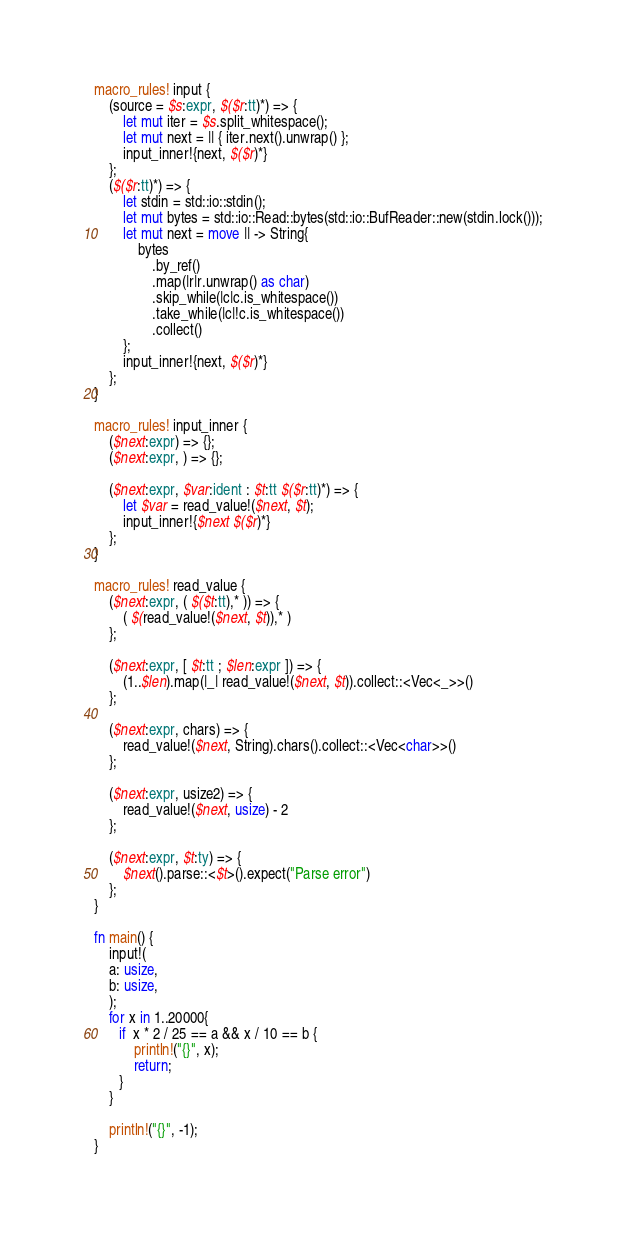Convert code to text. <code><loc_0><loc_0><loc_500><loc_500><_Rust_>macro_rules! input {
    (source = $s:expr, $($r:tt)*) => {
        let mut iter = $s.split_whitespace();
        let mut next = || { iter.next().unwrap() };
        input_inner!{next, $($r)*}
    };
    ($($r:tt)*) => {
        let stdin = std::io::stdin();
        let mut bytes = std::io::Read::bytes(std::io::BufReader::new(stdin.lock()));
        let mut next = move || -> String{
            bytes
                .by_ref()
                .map(|r|r.unwrap() as char)
                .skip_while(|c|c.is_whitespace())
                .take_while(|c|!c.is_whitespace())
                .collect()
        };
        input_inner!{next, $($r)*}
    };
}

macro_rules! input_inner {
    ($next:expr) => {};
    ($next:expr, ) => {};

    ($next:expr, $var:ident : $t:tt $($r:tt)*) => {
        let $var = read_value!($next, $t);
        input_inner!{$next $($r)*}
    };
}

macro_rules! read_value {
    ($next:expr, ( $($t:tt),* )) => {
        ( $(read_value!($next, $t)),* )
    };

    ($next:expr, [ $t:tt ; $len:expr ]) => {
        (1..$len).map(|_| read_value!($next, $t)).collect::<Vec<_>>()
    };

    ($next:expr, chars) => {
        read_value!($next, String).chars().collect::<Vec<char>>()
    };

    ($next:expr, usize2) => {
        read_value!($next, usize) - 2
    };

    ($next:expr, $t:ty) => {
        $next().parse::<$t>().expect("Parse error")
    };
}

fn main() {
    input!(
    a: usize,
    b: usize,
    );
    for x in 1..20000{
       if  x * 2 / 25 == a && x / 10 == b {
           println!("{}", x);
           return;
       }
    }

    println!("{}", -1);
}
</code> 